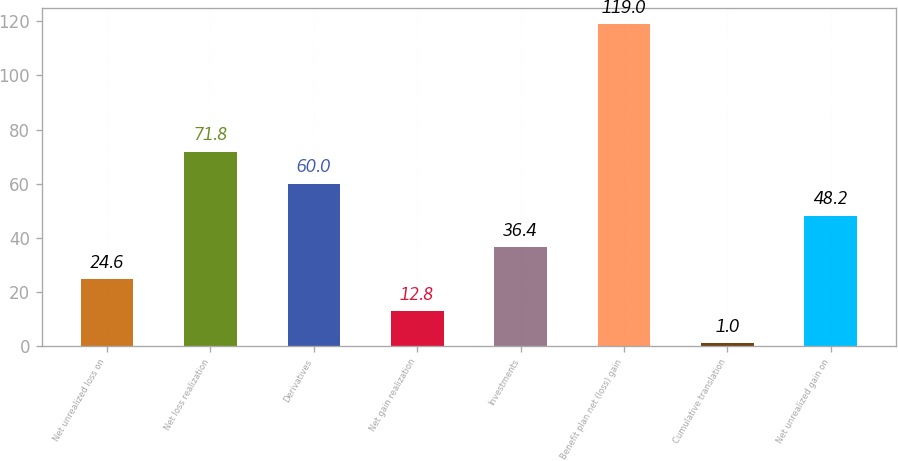Convert chart to OTSL. <chart><loc_0><loc_0><loc_500><loc_500><bar_chart><fcel>Net unrealized loss on<fcel>Net loss realization<fcel>Derivatives<fcel>Net gain realization<fcel>Investments<fcel>Benefit plan net (loss) gain<fcel>Cumulative translation<fcel>Net unrealized gain on<nl><fcel>24.6<fcel>71.8<fcel>60<fcel>12.8<fcel>36.4<fcel>119<fcel>1<fcel>48.2<nl></chart> 